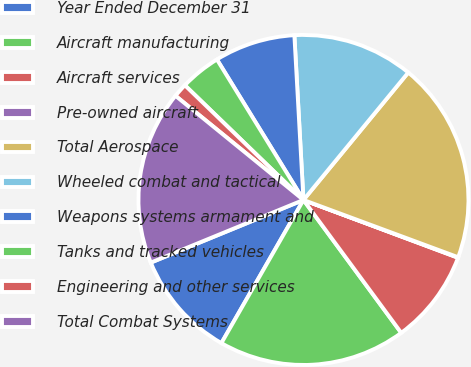Convert chart to OTSL. <chart><loc_0><loc_0><loc_500><loc_500><pie_chart><fcel>Year Ended December 31<fcel>Aircraft manufacturing<fcel>Aircraft services<fcel>Pre-owned aircraft<fcel>Total Aerospace<fcel>Wheeled combat and tactical<fcel>Weapons systems armament and<fcel>Tanks and tracked vehicles<fcel>Engineering and other services<fcel>Total Combat Systems<nl><fcel>10.52%<fcel>18.38%<fcel>9.21%<fcel>0.05%<fcel>19.69%<fcel>11.83%<fcel>7.91%<fcel>3.98%<fcel>1.36%<fcel>17.07%<nl></chart> 